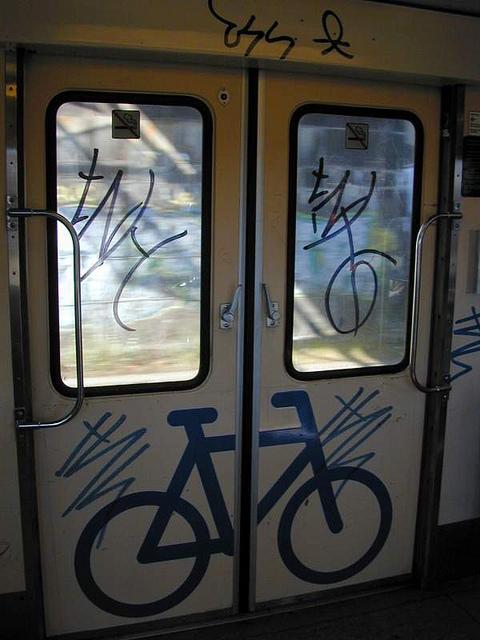Are the doors electric or pneumatic?
Quick response, please. Electric. What color are the doors?
Write a very short answer. White. What is on the train door?
Write a very short answer. Bike. How many wheels are drawn on the door?
Keep it brief. 2. What blue sigh is on the train?
Concise answer only. Bike. 